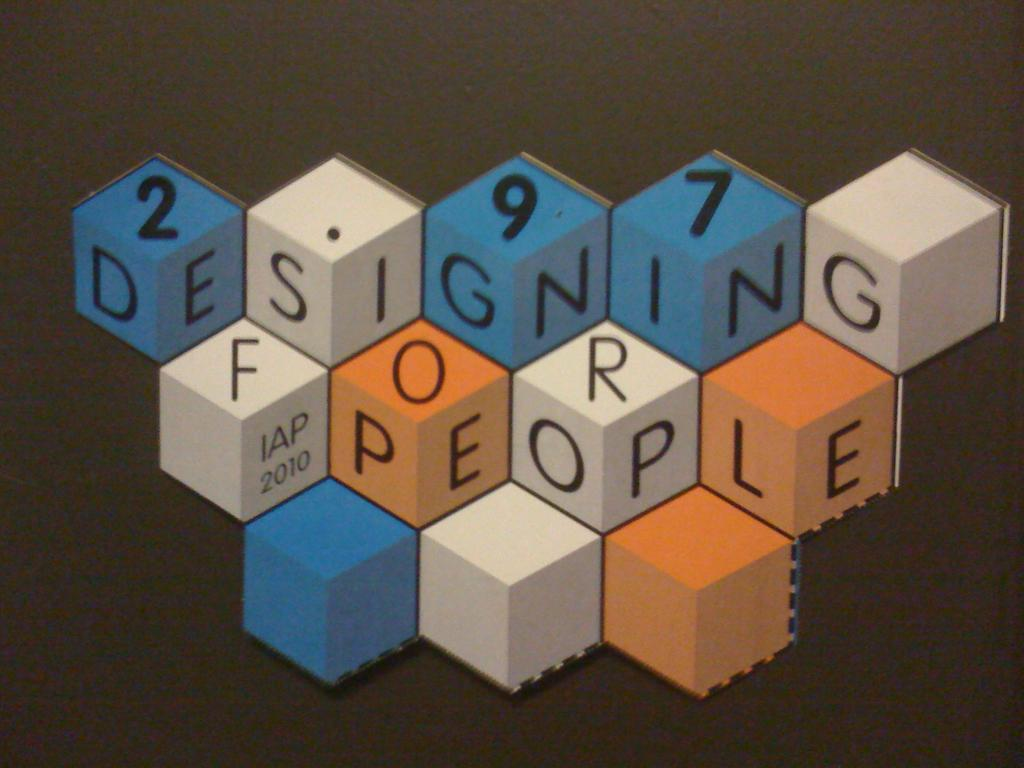Provide a one-sentence caption for the provided image. A series of blue, white, and orange blocks spell out designing for people, made by the company IAP in 2010. 